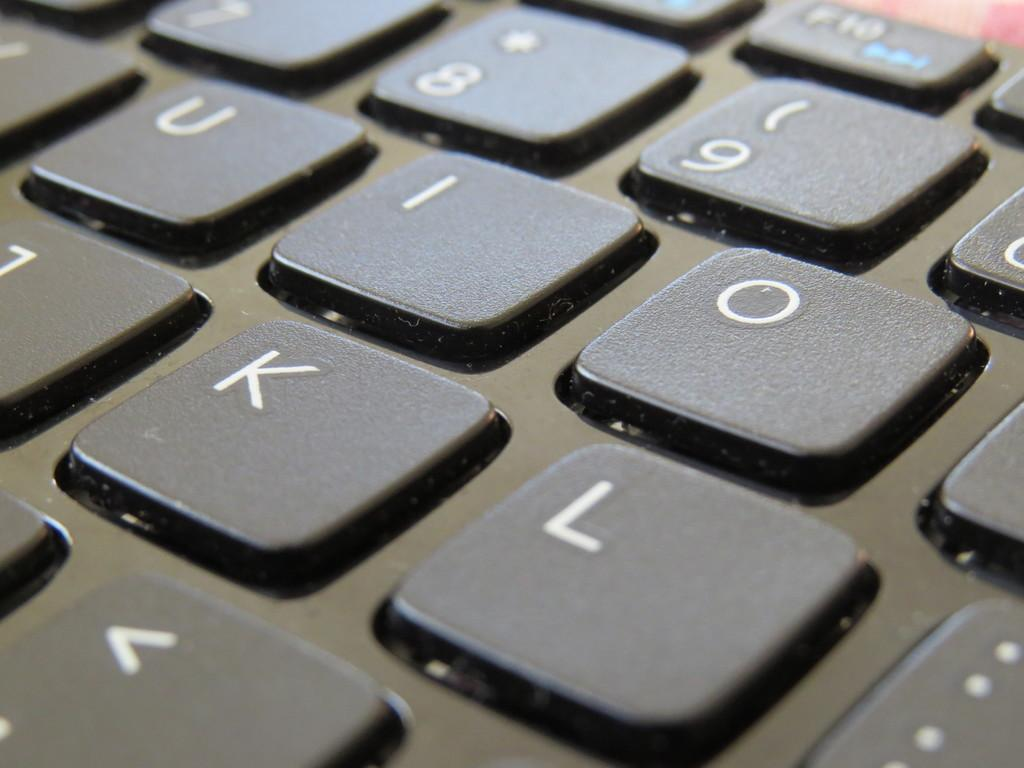Provide a one-sentence caption for the provided image. A zoomed in picture of keys with I, O, K and L in the focus. 